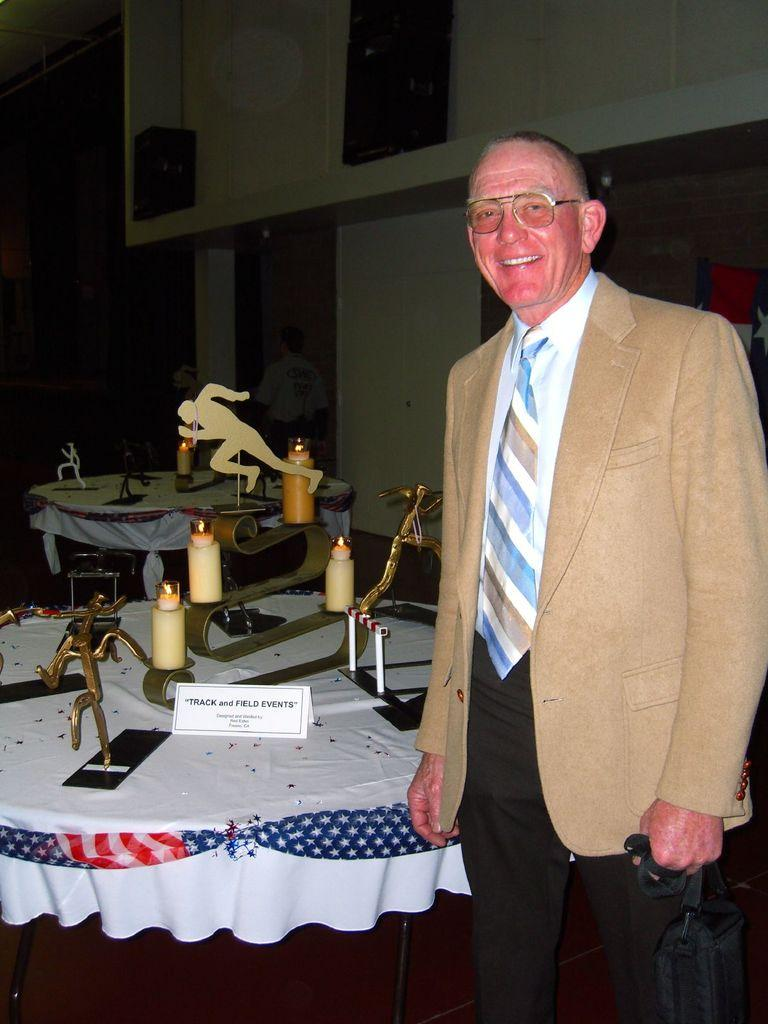What is the man in the image doing? The man is standing and smiling in the image. What can be seen on the wall in the background? There is a board in the image, which is likely on the wall. What is present on the tables in the image? There are objects on tables in the image. Can you describe the person in the background? There is a person in the background of the image, but no specific details are provided. What is the color or lighting condition of the background? The background of the image is dark. What type of debt is being discussed in the image? There is no mention of debt in the image. 